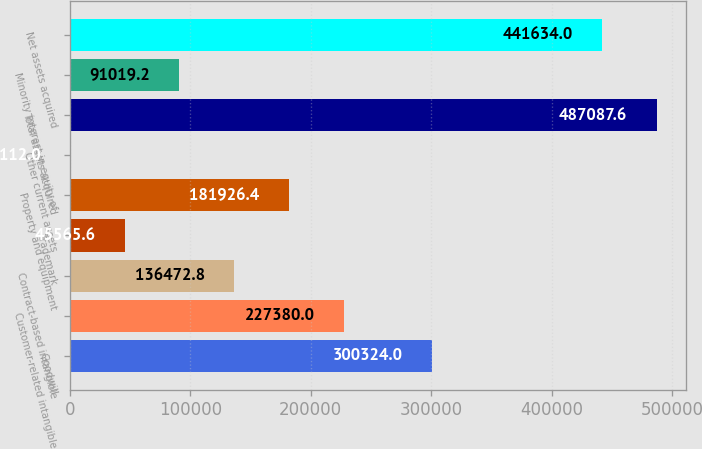<chart> <loc_0><loc_0><loc_500><loc_500><bar_chart><fcel>Goodwill<fcel>Customer-related intangible<fcel>Contract-based intangible<fcel>Trademark<fcel>Property and equipment<fcel>Other current assets<fcel>Total assets acquired<fcel>Minority interest in equity of<fcel>Net assets acquired<nl><fcel>300324<fcel>227380<fcel>136473<fcel>45565.6<fcel>181926<fcel>112<fcel>487088<fcel>91019.2<fcel>441634<nl></chart> 